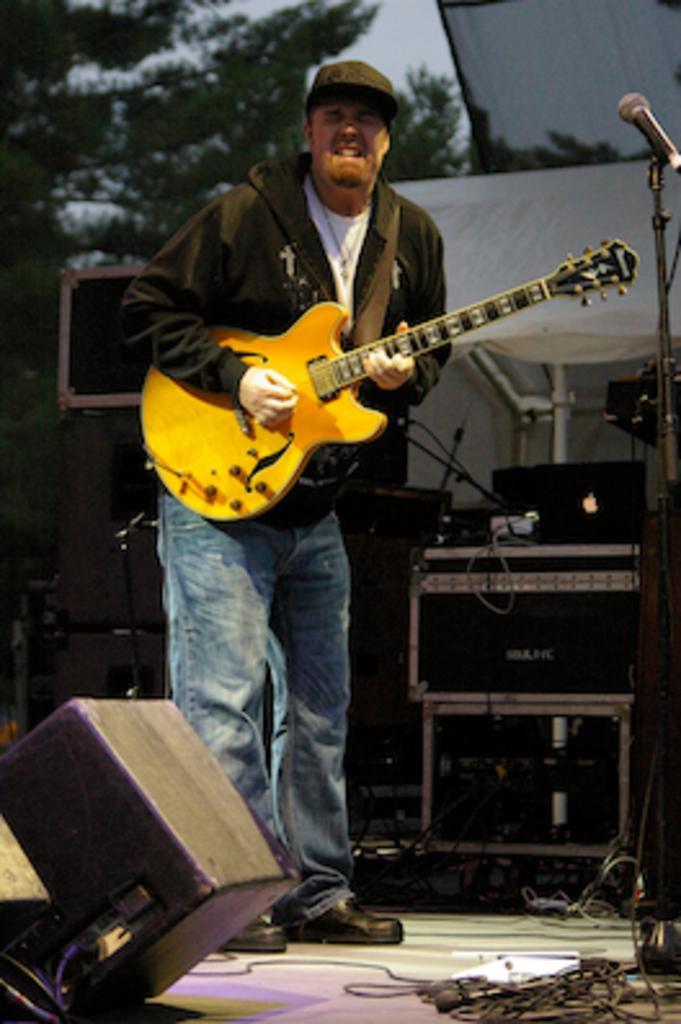Describe this image in one or two sentences. In this picture we can see a man standing on the stage and playing a guitar. On the stage we can also see a mike, wires, music systems, lights, etc., In the background we can see trees. 